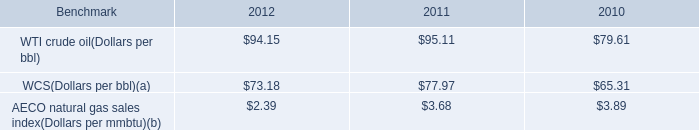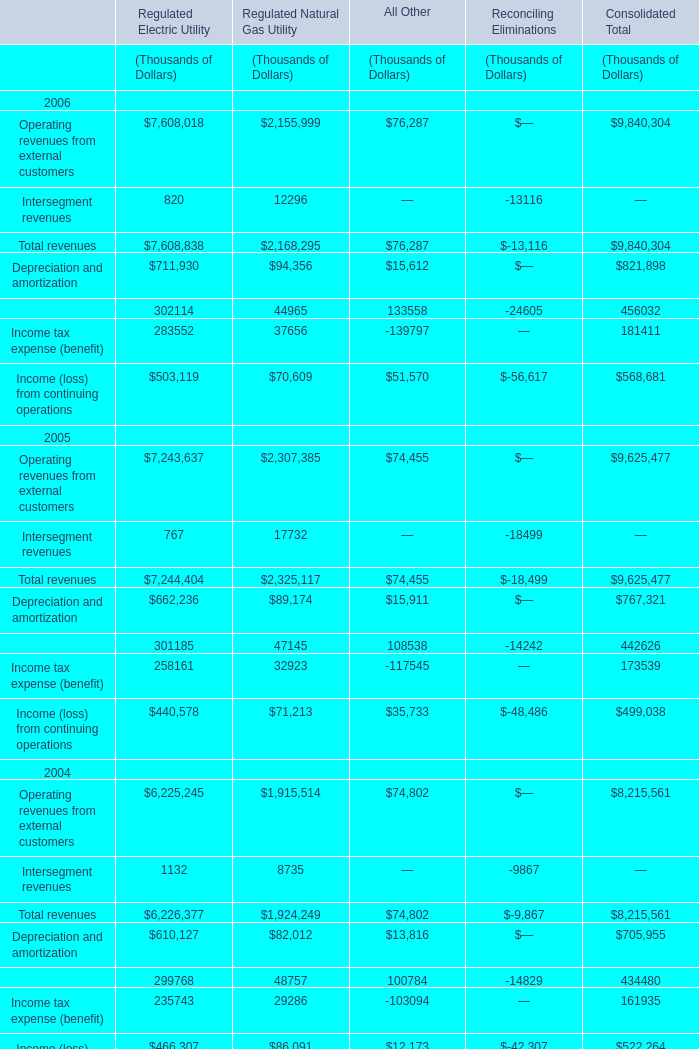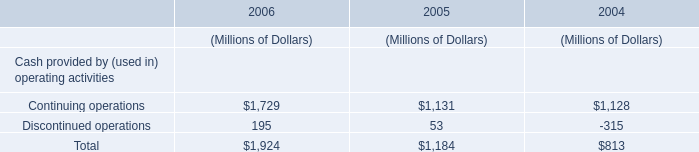What do all Regulated Electric Utility sum up without those Regulated Electric Utility smaller than 500000, in 2006? (in Thousand) 
Computations: ((7608018 + 711930) + 503119)
Answer: 8823067.0. 